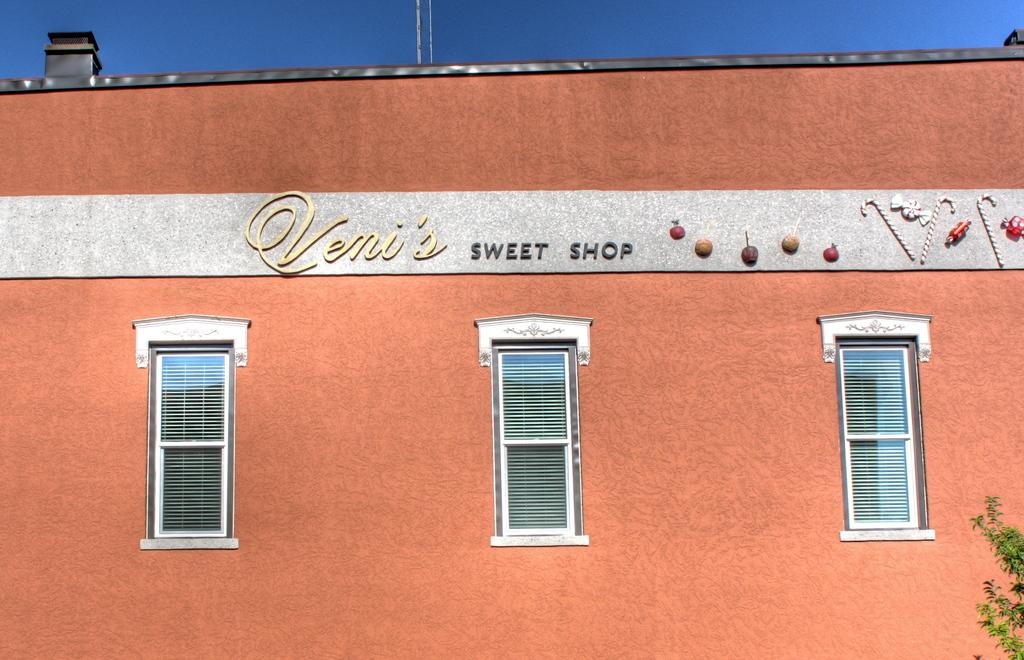What type of structure is visible in the image? There is a wall of a building in the image. What features can be seen on the building? The building has windows, text, and a design. What is visible at the top of the image? The sky is visible at the top of the image. What can be found in the bottom right corner of the image? There is a plant in the bottom right corner of the image. Is your aunt participating in the competition depicted in the image? There is no competition or aunt present in the image; it features a wall of a building with windows, text, and a design, as well as the sky and a plant. 